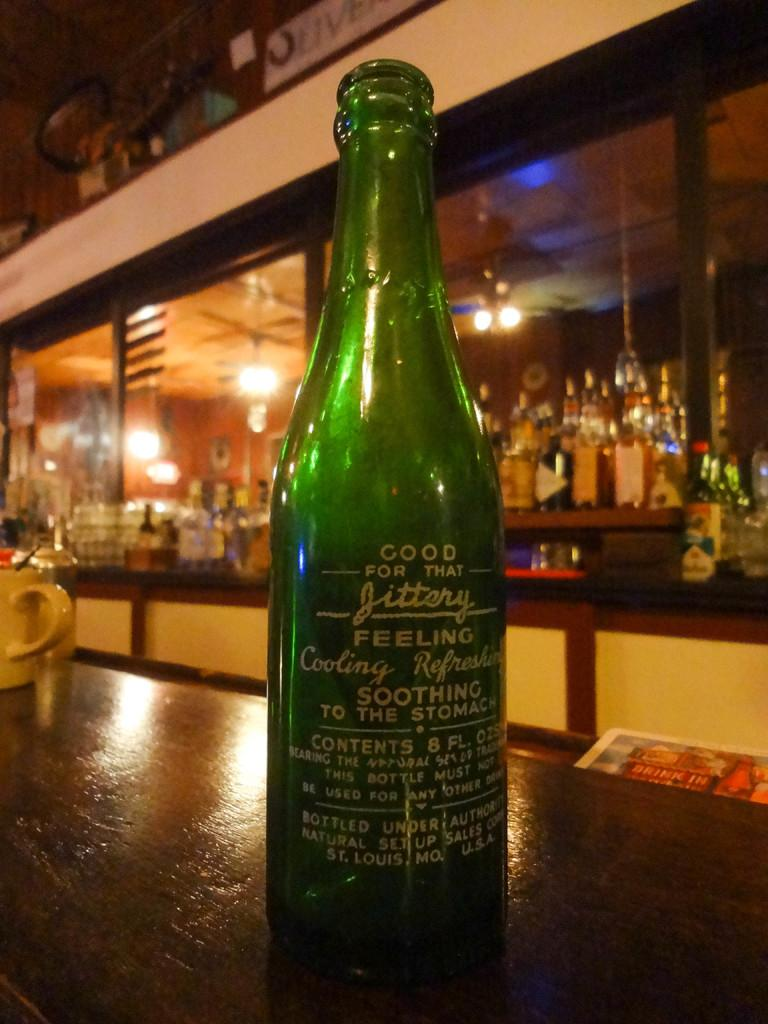<image>
Write a terse but informative summary of the picture. a green bottle that says its good for a jittery ffeeling is on a bar 